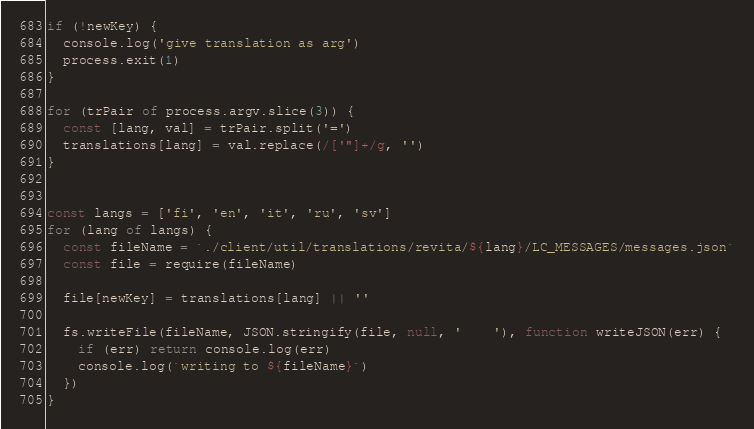Convert code to text. <code><loc_0><loc_0><loc_500><loc_500><_JavaScript_>
if (!newKey) {
  console.log('give translation as arg')
  process.exit(1)
}

for (trPair of process.argv.slice(3)) {
  const [lang, val] = trPair.split('=')
  translations[lang] = val.replace(/['"]+/g, '')
}


const langs = ['fi', 'en', 'it', 'ru', 'sv']
for (lang of langs) {
  const fileName = `./client/util/translations/revita/${lang}/LC_MESSAGES/messages.json`
  const file = require(fileName)

  file[newKey] = translations[lang] || ''

  fs.writeFile(fileName, JSON.stringify(file, null, '    '), function writeJSON(err) {
    if (err) return console.log(err)
    console.log(`writing to ${fileName}`)
  })
}

</code> 